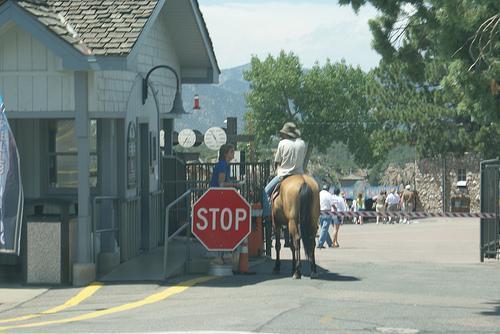How many horses are there?
Give a very brief answer. 1. 